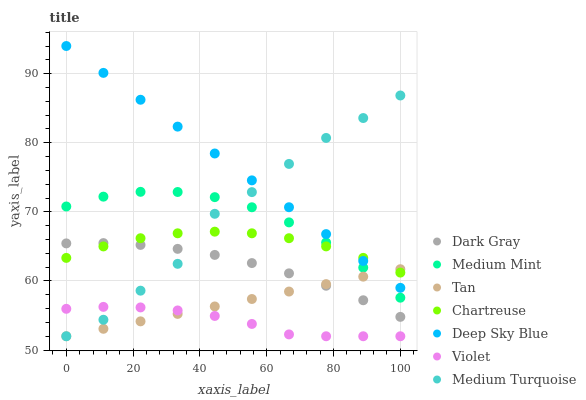Does Violet have the minimum area under the curve?
Answer yes or no. Yes. Does Deep Sky Blue have the maximum area under the curve?
Answer yes or no. Yes. Does Medium Turquoise have the minimum area under the curve?
Answer yes or no. No. Does Medium Turquoise have the maximum area under the curve?
Answer yes or no. No. Is Tan the smoothest?
Answer yes or no. Yes. Is Medium Turquoise the roughest?
Answer yes or no. Yes. Is Dark Gray the smoothest?
Answer yes or no. No. Is Dark Gray the roughest?
Answer yes or no. No. Does Medium Turquoise have the lowest value?
Answer yes or no. Yes. Does Dark Gray have the lowest value?
Answer yes or no. No. Does Deep Sky Blue have the highest value?
Answer yes or no. Yes. Does Medium Turquoise have the highest value?
Answer yes or no. No. Is Violet less than Medium Mint?
Answer yes or no. Yes. Is Medium Mint greater than Violet?
Answer yes or no. Yes. Does Tan intersect Dark Gray?
Answer yes or no. Yes. Is Tan less than Dark Gray?
Answer yes or no. No. Is Tan greater than Dark Gray?
Answer yes or no. No. Does Violet intersect Medium Mint?
Answer yes or no. No. 